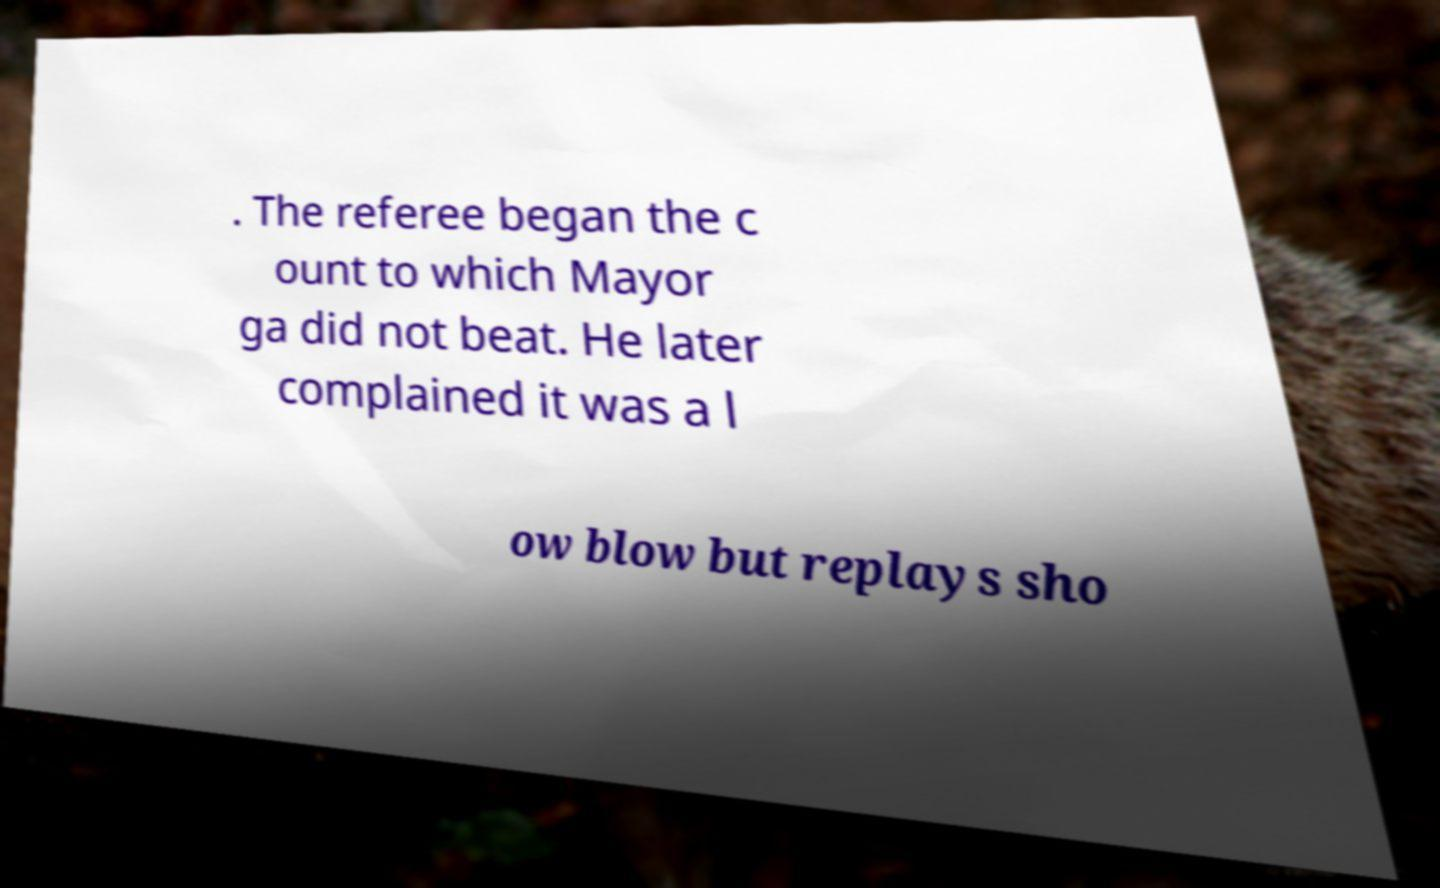I need the written content from this picture converted into text. Can you do that? . The referee began the c ount to which Mayor ga did not beat. He later complained it was a l ow blow but replays sho 